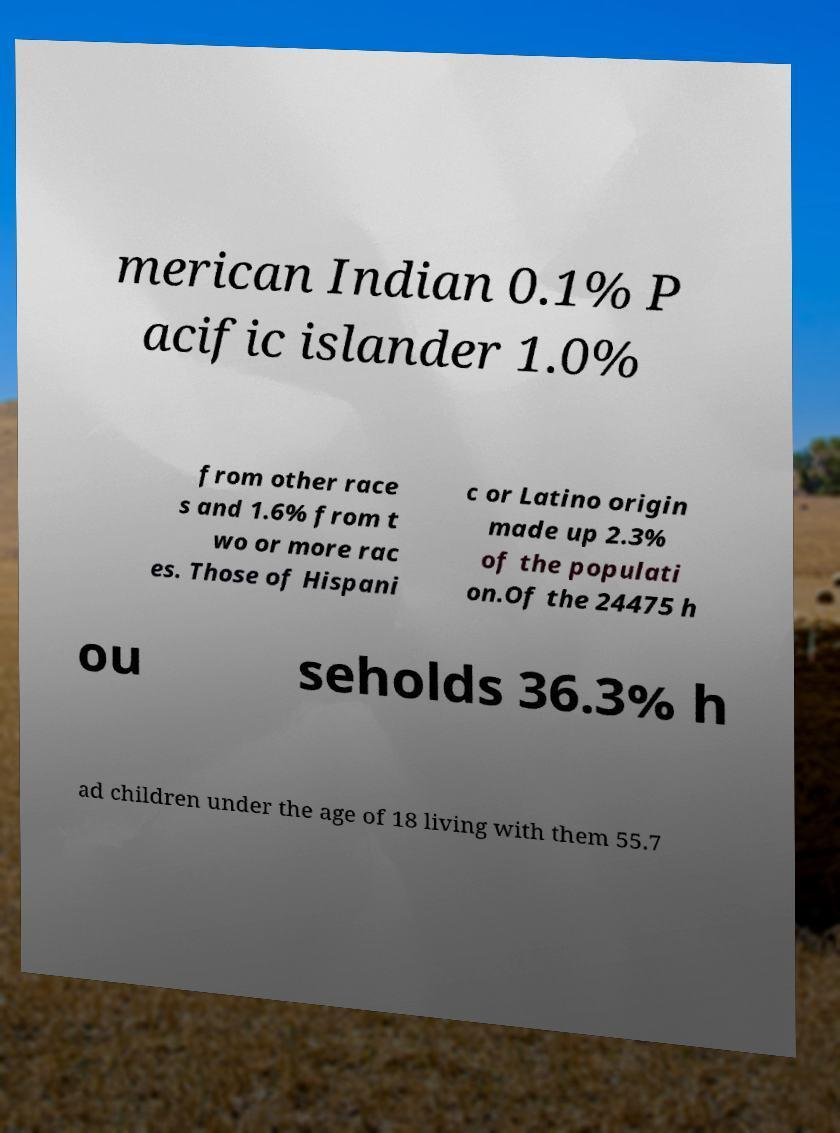Can you accurately transcribe the text from the provided image for me? merican Indian 0.1% P acific islander 1.0% from other race s and 1.6% from t wo or more rac es. Those of Hispani c or Latino origin made up 2.3% of the populati on.Of the 24475 h ou seholds 36.3% h ad children under the age of 18 living with them 55.7 